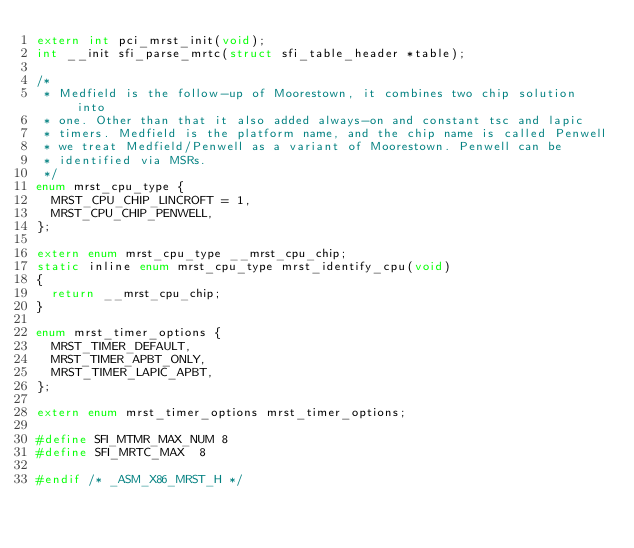Convert code to text. <code><loc_0><loc_0><loc_500><loc_500><_C_>extern int pci_mrst_init(void);
int __init sfi_parse_mrtc(struct sfi_table_header *table);

/*
 * Medfield is the follow-up of Moorestown, it combines two chip solution into
 * one. Other than that it also added always-on and constant tsc and lapic
 * timers. Medfield is the platform name, and the chip name is called Penwell
 * we treat Medfield/Penwell as a variant of Moorestown. Penwell can be
 * identified via MSRs.
 */
enum mrst_cpu_type {
	MRST_CPU_CHIP_LINCROFT = 1,
	MRST_CPU_CHIP_PENWELL,
};

extern enum mrst_cpu_type __mrst_cpu_chip;
static inline enum mrst_cpu_type mrst_identify_cpu(void)
{
	return __mrst_cpu_chip;
}

enum mrst_timer_options {
	MRST_TIMER_DEFAULT,
	MRST_TIMER_APBT_ONLY,
	MRST_TIMER_LAPIC_APBT,
};

extern enum mrst_timer_options mrst_timer_options;

#define SFI_MTMR_MAX_NUM 8
#define SFI_MRTC_MAX	8

#endif /* _ASM_X86_MRST_H */
</code> 